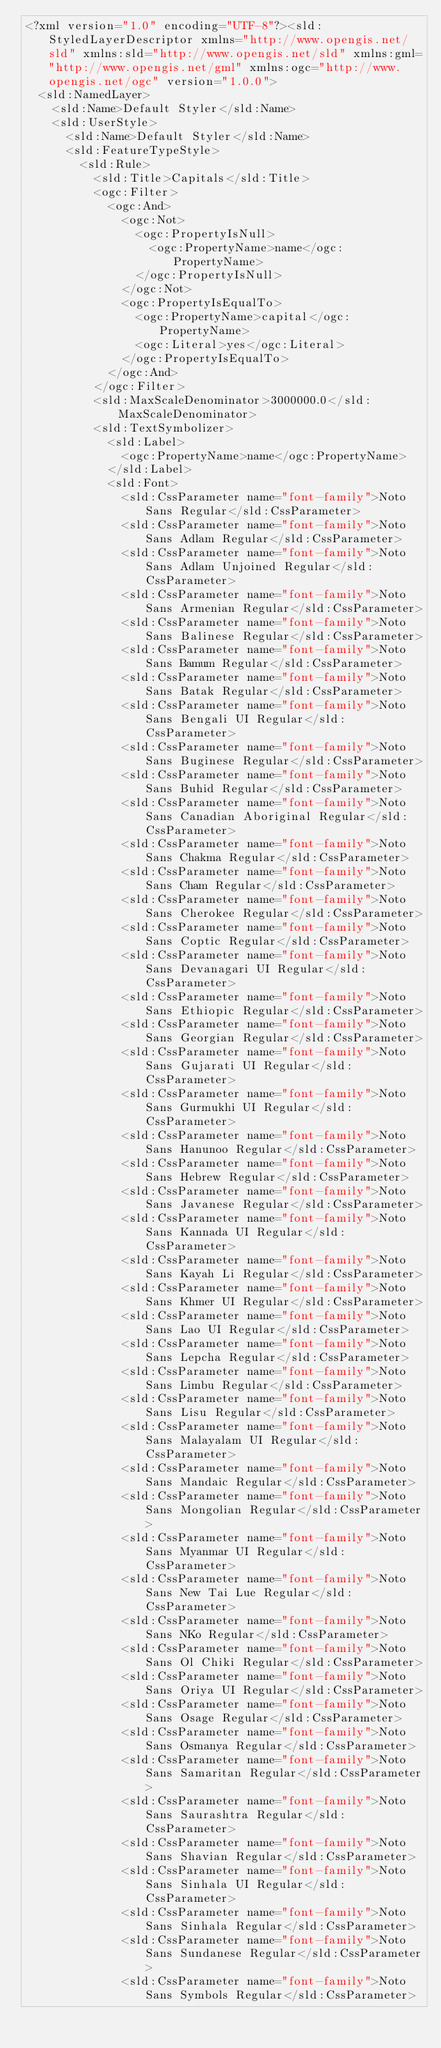Convert code to text. <code><loc_0><loc_0><loc_500><loc_500><_Scheme_><?xml version="1.0" encoding="UTF-8"?><sld:StyledLayerDescriptor xmlns="http://www.opengis.net/sld" xmlns:sld="http://www.opengis.net/sld" xmlns:gml="http://www.opengis.net/gml" xmlns:ogc="http://www.opengis.net/ogc" version="1.0.0">
  <sld:NamedLayer>
    <sld:Name>Default Styler</sld:Name>
    <sld:UserStyle>
      <sld:Name>Default Styler</sld:Name>
      <sld:FeatureTypeStyle>
        <sld:Rule>
          <sld:Title>Capitals</sld:Title>
          <ogc:Filter>
            <ogc:And>
              <ogc:Not>
                <ogc:PropertyIsNull>
                  <ogc:PropertyName>name</ogc:PropertyName>
                </ogc:PropertyIsNull>
              </ogc:Not>
              <ogc:PropertyIsEqualTo>
                <ogc:PropertyName>capital</ogc:PropertyName>
                <ogc:Literal>yes</ogc:Literal>
              </ogc:PropertyIsEqualTo>
            </ogc:And>
          </ogc:Filter>
          <sld:MaxScaleDenominator>3000000.0</sld:MaxScaleDenominator>
          <sld:TextSymbolizer>
            <sld:Label>
              <ogc:PropertyName>name</ogc:PropertyName>
            </sld:Label>
            <sld:Font>
              <sld:CssParameter name="font-family">Noto Sans Regular</sld:CssParameter>
              <sld:CssParameter name="font-family">Noto Sans Adlam Regular</sld:CssParameter>
              <sld:CssParameter name="font-family">Noto Sans Adlam Unjoined Regular</sld:CssParameter>
              <sld:CssParameter name="font-family">Noto Sans Armenian Regular</sld:CssParameter>
              <sld:CssParameter name="font-family">Noto Sans Balinese Regular</sld:CssParameter>
              <sld:CssParameter name="font-family">Noto Sans Bamum Regular</sld:CssParameter>
              <sld:CssParameter name="font-family">Noto Sans Batak Regular</sld:CssParameter>
              <sld:CssParameter name="font-family">Noto Sans Bengali UI Regular</sld:CssParameter>
              <sld:CssParameter name="font-family">Noto Sans Buginese Regular</sld:CssParameter>
              <sld:CssParameter name="font-family">Noto Sans Buhid Regular</sld:CssParameter>
              <sld:CssParameter name="font-family">Noto Sans Canadian Aboriginal Regular</sld:CssParameter>
              <sld:CssParameter name="font-family">Noto Sans Chakma Regular</sld:CssParameter>
              <sld:CssParameter name="font-family">Noto Sans Cham Regular</sld:CssParameter>
              <sld:CssParameter name="font-family">Noto Sans Cherokee Regular</sld:CssParameter>
              <sld:CssParameter name="font-family">Noto Sans Coptic Regular</sld:CssParameter>
              <sld:CssParameter name="font-family">Noto Sans Devanagari UI Regular</sld:CssParameter>
              <sld:CssParameter name="font-family">Noto Sans Ethiopic Regular</sld:CssParameter>
              <sld:CssParameter name="font-family">Noto Sans Georgian Regular</sld:CssParameter>
              <sld:CssParameter name="font-family">Noto Sans Gujarati UI Regular</sld:CssParameter>
              <sld:CssParameter name="font-family">Noto Sans Gurmukhi UI Regular</sld:CssParameter>
              <sld:CssParameter name="font-family">Noto Sans Hanunoo Regular</sld:CssParameter>
              <sld:CssParameter name="font-family">Noto Sans Hebrew Regular</sld:CssParameter>
              <sld:CssParameter name="font-family">Noto Sans Javanese Regular</sld:CssParameter>
              <sld:CssParameter name="font-family">Noto Sans Kannada UI Regular</sld:CssParameter>
              <sld:CssParameter name="font-family">Noto Sans Kayah Li Regular</sld:CssParameter>
              <sld:CssParameter name="font-family">Noto Sans Khmer UI Regular</sld:CssParameter>
              <sld:CssParameter name="font-family">Noto Sans Lao UI Regular</sld:CssParameter>
              <sld:CssParameter name="font-family">Noto Sans Lepcha Regular</sld:CssParameter>
              <sld:CssParameter name="font-family">Noto Sans Limbu Regular</sld:CssParameter>
              <sld:CssParameter name="font-family">Noto Sans Lisu Regular</sld:CssParameter>
              <sld:CssParameter name="font-family">Noto Sans Malayalam UI Regular</sld:CssParameter>
              <sld:CssParameter name="font-family">Noto Sans Mandaic Regular</sld:CssParameter>
              <sld:CssParameter name="font-family">Noto Sans Mongolian Regular</sld:CssParameter>
              <sld:CssParameter name="font-family">Noto Sans Myanmar UI Regular</sld:CssParameter>
              <sld:CssParameter name="font-family">Noto Sans New Tai Lue Regular</sld:CssParameter>
              <sld:CssParameter name="font-family">Noto Sans NKo Regular</sld:CssParameter>
              <sld:CssParameter name="font-family">Noto Sans Ol Chiki Regular</sld:CssParameter>
              <sld:CssParameter name="font-family">Noto Sans Oriya UI Regular</sld:CssParameter>
              <sld:CssParameter name="font-family">Noto Sans Osage Regular</sld:CssParameter>
              <sld:CssParameter name="font-family">Noto Sans Osmanya Regular</sld:CssParameter>
              <sld:CssParameter name="font-family">Noto Sans Samaritan Regular</sld:CssParameter>
              <sld:CssParameter name="font-family">Noto Sans Saurashtra Regular</sld:CssParameter>
              <sld:CssParameter name="font-family">Noto Sans Shavian Regular</sld:CssParameter>
              <sld:CssParameter name="font-family">Noto Sans Sinhala UI Regular</sld:CssParameter>
              <sld:CssParameter name="font-family">Noto Sans Sinhala Regular</sld:CssParameter>
              <sld:CssParameter name="font-family">Noto Sans Sundanese Regular</sld:CssParameter>
              <sld:CssParameter name="font-family">Noto Sans Symbols Regular</sld:CssParameter></code> 